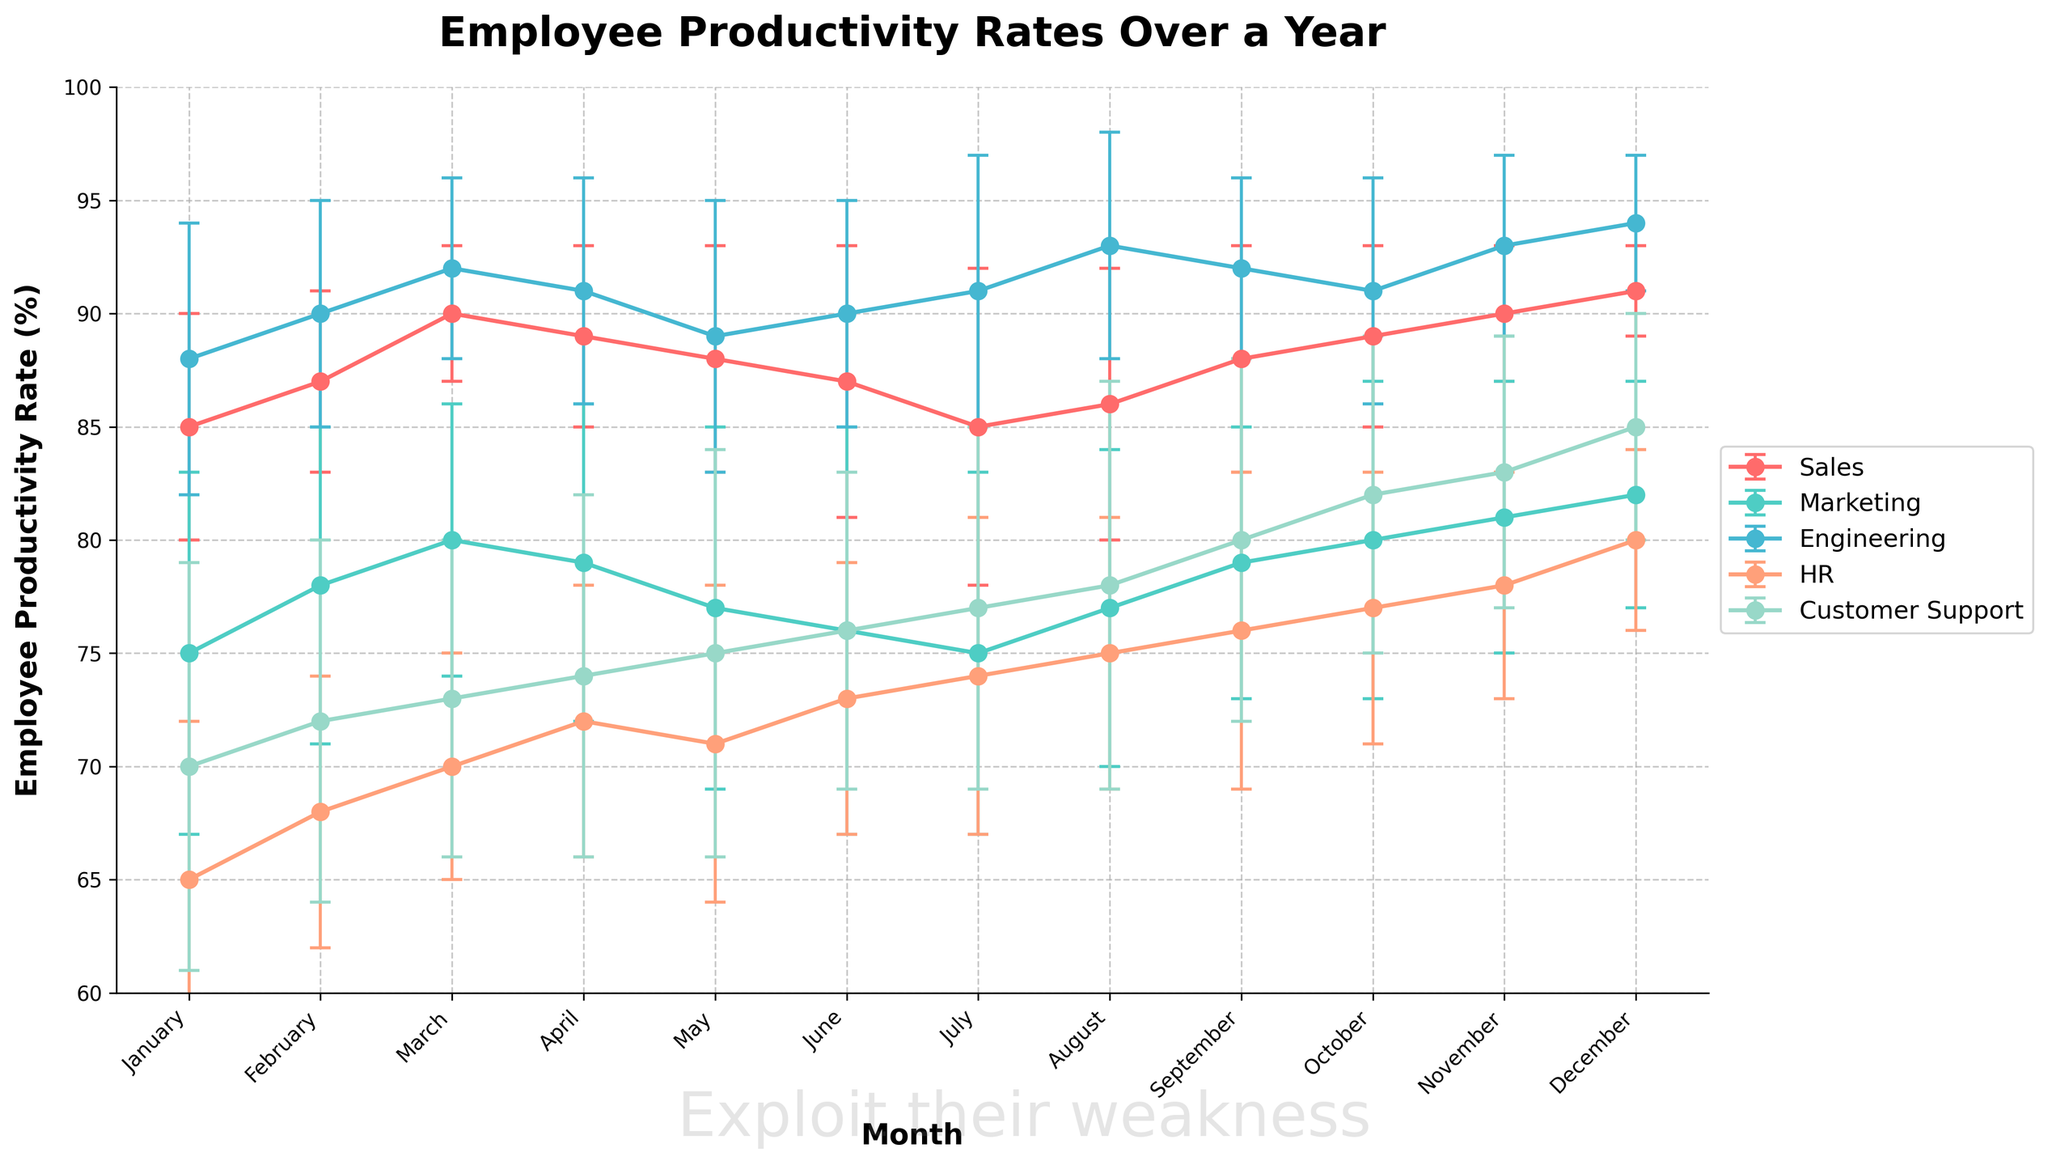What is the title of the plot? The title of the plot is located at the top and reads 'Employee Productivity Rates Over a Year'.
Answer: Employee Productivity Rates Over a Year What is the Employee Productivity Rate for the Engineering department in December? Locate the data point for December along the x-axis and find the corresponding value for the Engineering department line, which is marked with error bars. The value is 94%.
Answer: 94% Which department has the lowest productivity rate in January? Look at the y-axis values for January for each department. The HR department line reaches the lowest point at 65%.
Answer: HR What is the average productivity rate of the Sales department for the first quarter (January, February, March)? Identify the productivity rates for Sales in January (85), February (87), and March (90). Calculate the average (85 + 87 + 90) / 3.
Answer: 87.33% How does the productivity rate of Marketing compare to Customer Support in October? Find the October data points for both Marketing and Customer Support. Marketing is at 80%, and Customer Support is at 82%. Customer Support is higher.
Answer: Customer Support is higher What is the highest recorded productivity rate across all months for any department? Scan the highest peaks across all lines and months. The highest point is for the Engineering department in December at 94%.
Answer: 94% By how much did the HR department's productivity rate change from January to December? Find the HR data points for January (65%) and December (80%). Calculate the difference (80 - 65).
Answer: 15% Which month shows the highest productivity rate for Engineering? Follow the Engineering line to find the highest peak, which is in December with a rate of 94%.
Answer: December Compare the error bars for Sales in January and July. Which month had more variability? Examine the lengths of the error bars for Sales in January and July. July’s error bar is longer, indicating higher variability.
Answer: July What is the trend of Customer Support's productivity rate from June to December? Follow the Customer Support line from June (76%) to December (85%). The trend is generally increasing.
Answer: Increasing 